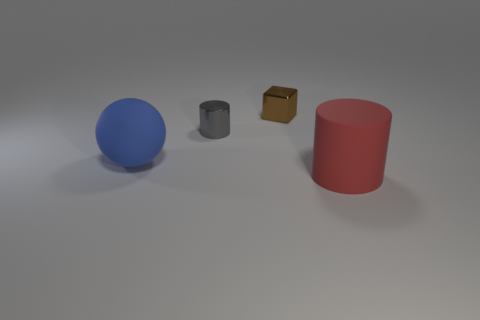What number of objects are both on the right side of the tiny cylinder and behind the big blue rubber ball?
Give a very brief answer. 1. There is a tiny brown thing that is left of the large object in front of the big thing that is to the left of the tiny metallic block; what is its shape?
Your answer should be very brief. Cube. Are there any other things that have the same shape as the big blue rubber object?
Provide a succinct answer. No. What number of blocks are either large rubber things or tiny gray metal objects?
Keep it short and to the point. 0. Do the large rubber thing that is left of the gray thing and the matte cylinder have the same color?
Make the answer very short. No. There is a thing that is behind the small gray metallic cylinder that is left of the large red rubber cylinder in front of the tiny metallic cube; what is its material?
Your answer should be very brief. Metal. Do the block and the red rubber cylinder have the same size?
Offer a terse response. No. There is a cube; is it the same color as the matte thing in front of the blue rubber sphere?
Keep it short and to the point. No. What shape is the blue object that is made of the same material as the big red cylinder?
Offer a terse response. Sphere. Does the rubber object that is behind the red matte thing have the same shape as the gray thing?
Offer a very short reply. No. 